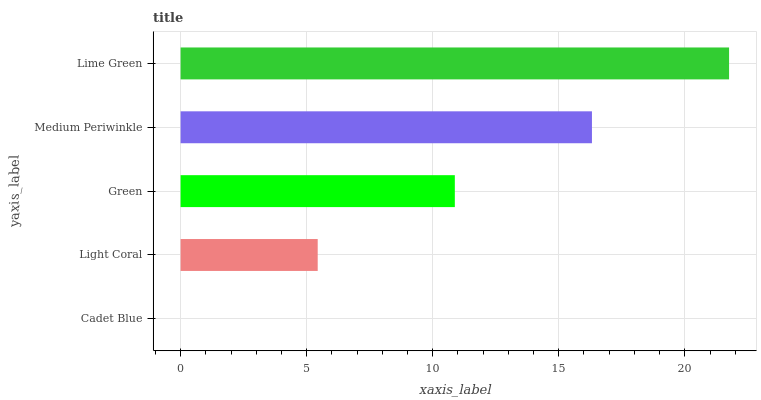Is Cadet Blue the minimum?
Answer yes or no. Yes. Is Lime Green the maximum?
Answer yes or no. Yes. Is Light Coral the minimum?
Answer yes or no. No. Is Light Coral the maximum?
Answer yes or no. No. Is Light Coral greater than Cadet Blue?
Answer yes or no. Yes. Is Cadet Blue less than Light Coral?
Answer yes or no. Yes. Is Cadet Blue greater than Light Coral?
Answer yes or no. No. Is Light Coral less than Cadet Blue?
Answer yes or no. No. Is Green the high median?
Answer yes or no. Yes. Is Green the low median?
Answer yes or no. Yes. Is Light Coral the high median?
Answer yes or no. No. Is Lime Green the low median?
Answer yes or no. No. 